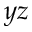Convert formula to latex. <formula><loc_0><loc_0><loc_500><loc_500>y z</formula> 